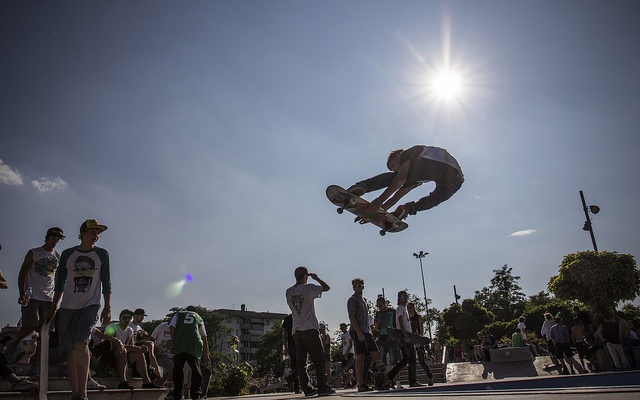Describe the objects in this image and their specific colors. I can see people in black, gray, and darkgreen tones, people in black, darkgray, and gray tones, people in black and gray tones, people in black and gray tones, and people in black and gray tones in this image. 